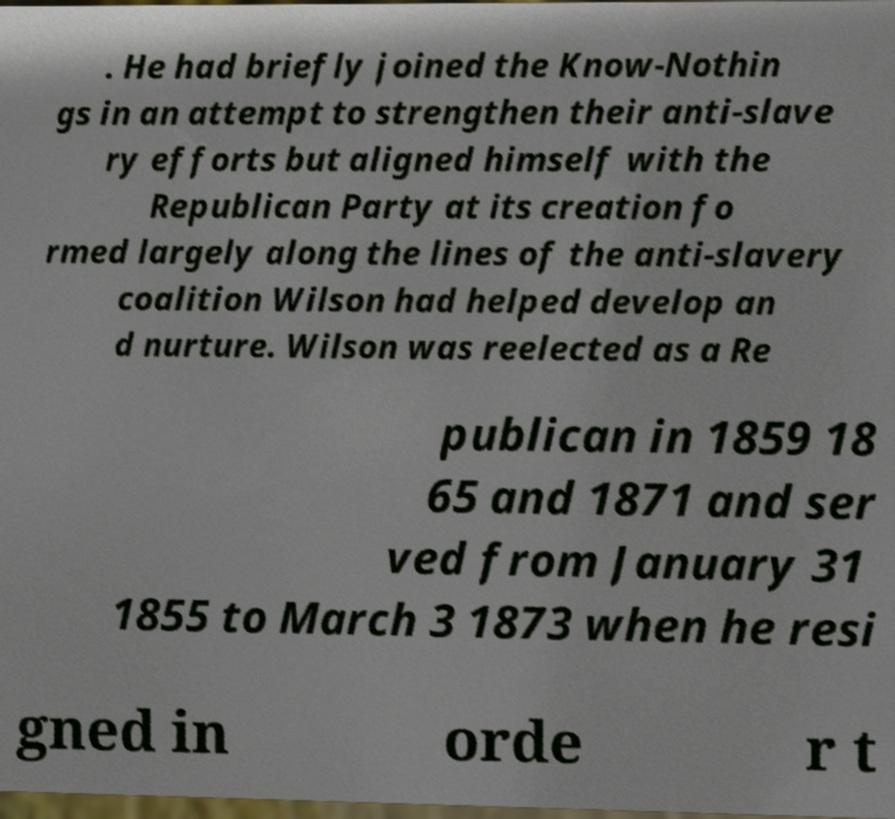There's text embedded in this image that I need extracted. Can you transcribe it verbatim? . He had briefly joined the Know-Nothin gs in an attempt to strengthen their anti-slave ry efforts but aligned himself with the Republican Party at its creation fo rmed largely along the lines of the anti-slavery coalition Wilson had helped develop an d nurture. Wilson was reelected as a Re publican in 1859 18 65 and 1871 and ser ved from January 31 1855 to March 3 1873 when he resi gned in orde r t 